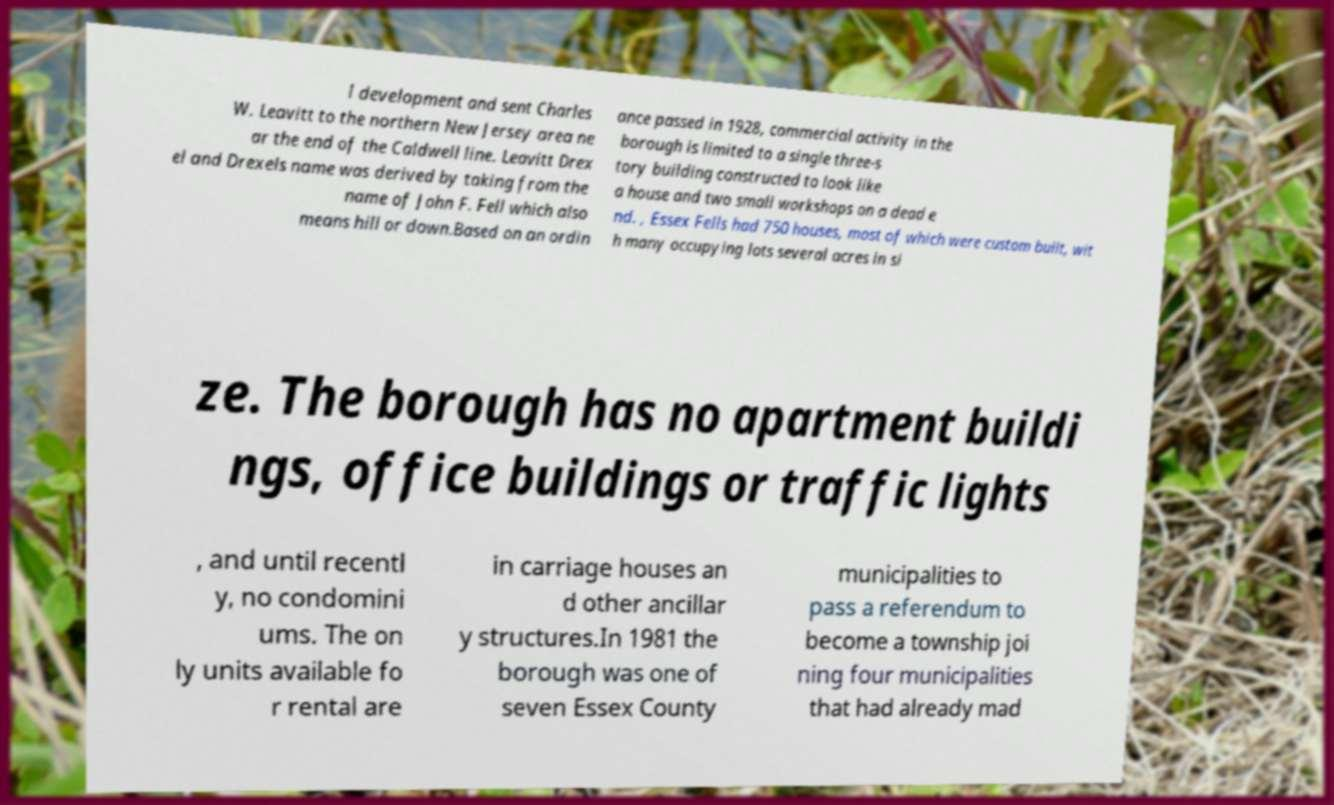Please read and relay the text visible in this image. What does it say? l development and sent Charles W. Leavitt to the northern New Jersey area ne ar the end of the Caldwell line. Leavitt Drex el and Drexels name was derived by taking from the name of John F. Fell which also means hill or down.Based on an ordin ance passed in 1928, commercial activity in the borough is limited to a single three-s tory building constructed to look like a house and two small workshops on a dead e nd. , Essex Fells had 750 houses, most of which were custom built, wit h many occupying lots several acres in si ze. The borough has no apartment buildi ngs, office buildings or traffic lights , and until recentl y, no condomini ums. The on ly units available fo r rental are in carriage houses an d other ancillar y structures.In 1981 the borough was one of seven Essex County municipalities to pass a referendum to become a township joi ning four municipalities that had already mad 